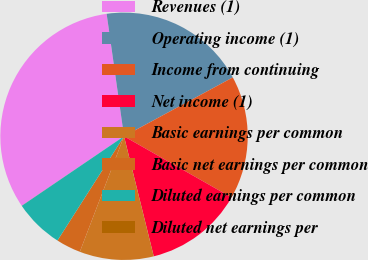Convert chart to OTSL. <chart><loc_0><loc_0><loc_500><loc_500><pie_chart><fcel>Revenues (1)<fcel>Operating income (1)<fcel>Income from continuing<fcel>Net income (1)<fcel>Basic earnings per common<fcel>Basic net earnings per common<fcel>Diluted earnings per common<fcel>Diluted net earnings per<nl><fcel>32.25%<fcel>19.35%<fcel>16.13%<fcel>12.9%<fcel>9.68%<fcel>3.23%<fcel>6.45%<fcel>0.01%<nl></chart> 